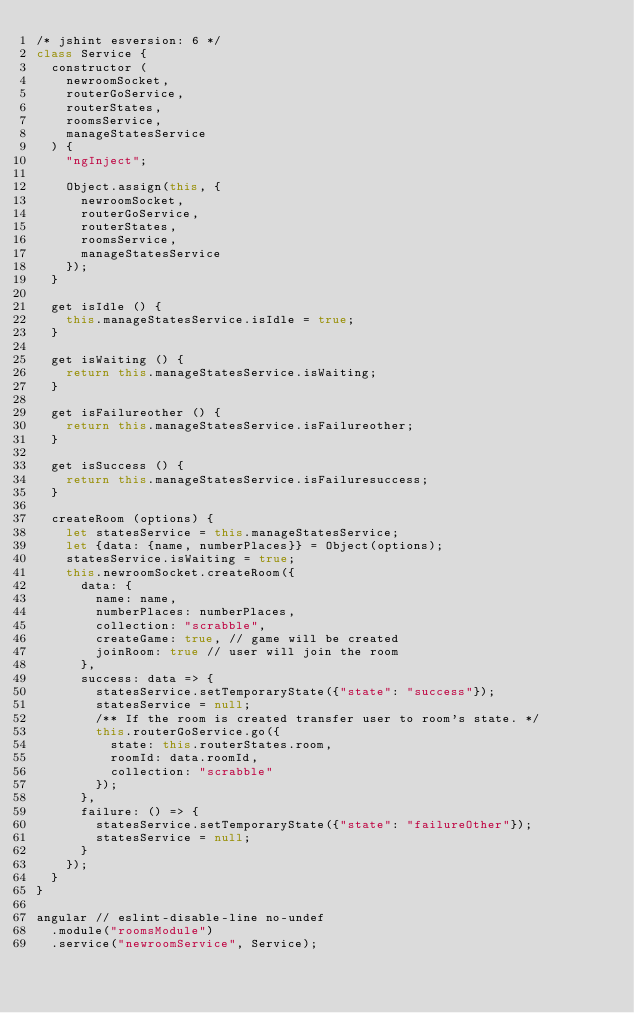<code> <loc_0><loc_0><loc_500><loc_500><_JavaScript_>/* jshint esversion: 6 */
class Service {
  constructor (
    newroomSocket,
    routerGoService,
    routerStates,
    roomsService,
    manageStatesService
  ) {
    "ngInject";

    Object.assign(this, {
      newroomSocket,
      routerGoService,
      routerStates,
      roomsService,
      manageStatesService
    });
  }

  get isIdle () {
    this.manageStatesService.isIdle = true;
  }

  get isWaiting () {
    return this.manageStatesService.isWaiting;
  }

  get isFailureother () {
    return this.manageStatesService.isFailureother;
  }

  get isSuccess () {
    return this.manageStatesService.isFailuresuccess;
  }

  createRoom (options) {
    let statesService = this.manageStatesService;
    let {data: {name, numberPlaces}} = Object(options);
    statesService.isWaiting = true;
    this.newroomSocket.createRoom({
      data: {
        name: name,
        numberPlaces: numberPlaces,
        collection: "scrabble",
        createGame: true, // game will be created
        joinRoom: true // user will join the room
      },
      success: data => {
        statesService.setTemporaryState({"state": "success"});
        statesService = null;
        /** If the room is created transfer user to room's state. */
        this.routerGoService.go({
          state: this.routerStates.room,
          roomId: data.roomId,
          collection: "scrabble"
        });
      },
      failure: () => {
        statesService.setTemporaryState({"state": "failureOther"});
        statesService = null;
      }
    });
  }
}

angular // eslint-disable-line no-undef
  .module("roomsModule")
  .service("newroomService", Service);
</code> 